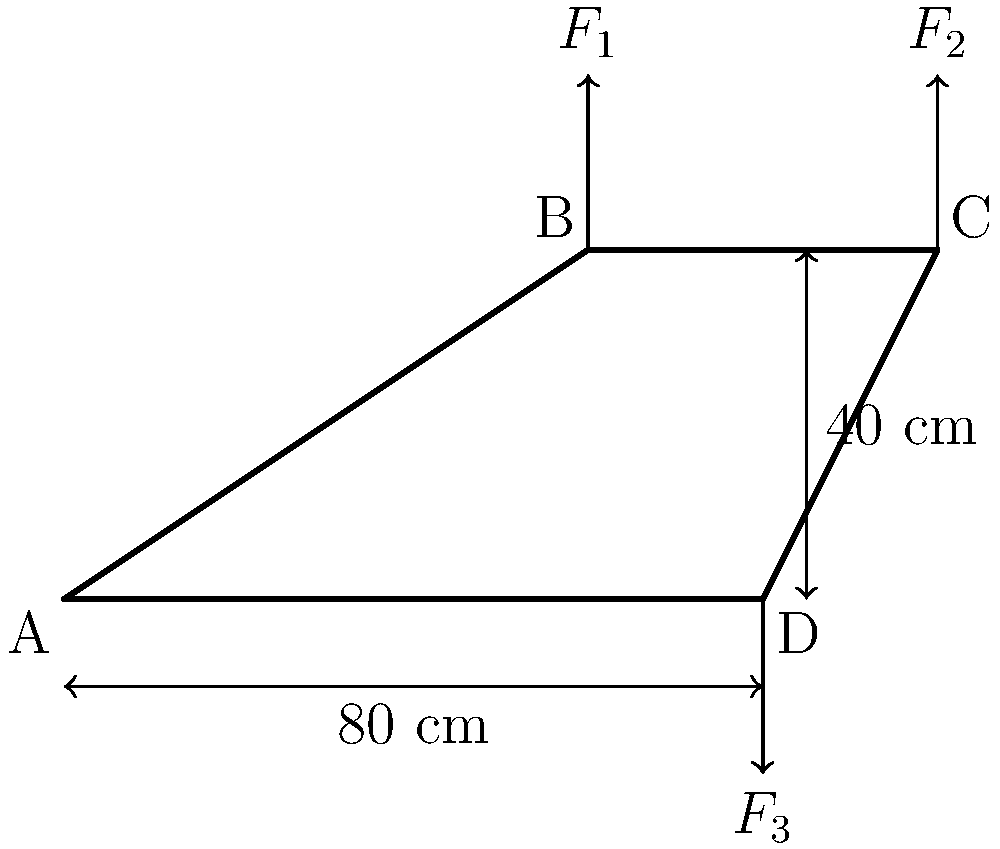A simplified bicycle frame is shown above. If a vertical force $F_1 = 600$ N is applied at point B, and $F_2 = 400$ N at point C, what should be the magnitude of force $F_3$ at point D to maintain equilibrium? Assume the frame is rigid and ignore its weight. To solve this problem, we'll use the principle of moments and the equilibrium condition.

Step 1: Choose a pivot point. Let's choose point A as our pivot.

Step 2: Calculate the moments caused by $F_1$ and $F_2$ about point A.
Moment of $F_1$: $M_1 = F_1 \times 60$ cm $= 600$ N $\times 0.6$ m $= 360$ N·m (clockwise)
Moment of $F_2$: $M_2 = F_2 \times 100$ cm $= 400$ N $\times 1.0$ m $= 400$ N·m (clockwise)

Step 3: Calculate the total clockwise moment.
$M_{total} = M_1 + M_2 = 360 + 400 = 760$ N·m

Step 4: For equilibrium, the counterclockwise moment caused by $F_3$ must equal the total clockwise moment.
$F_3 \times 80$ cm $= 760$ N·m

Step 5: Solve for $F_3$.
$F_3 = \frac{760 \text{ N·m}}{0.8 \text{ m}} = 950$ N

Therefore, a force of 950 N applied vertically upward at point D will maintain equilibrium.
Answer: 950 N 